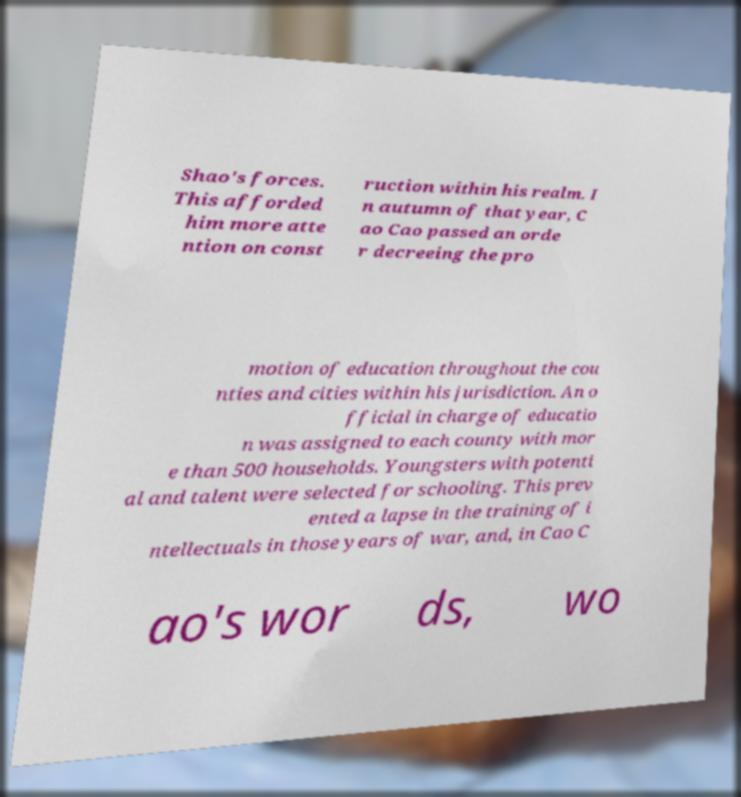Could you extract and type out the text from this image? Shao's forces. This afforded him more atte ntion on const ruction within his realm. I n autumn of that year, C ao Cao passed an orde r decreeing the pro motion of education throughout the cou nties and cities within his jurisdiction. An o fficial in charge of educatio n was assigned to each county with mor e than 500 households. Youngsters with potenti al and talent were selected for schooling. This prev ented a lapse in the training of i ntellectuals in those years of war, and, in Cao C ao's wor ds, wo 